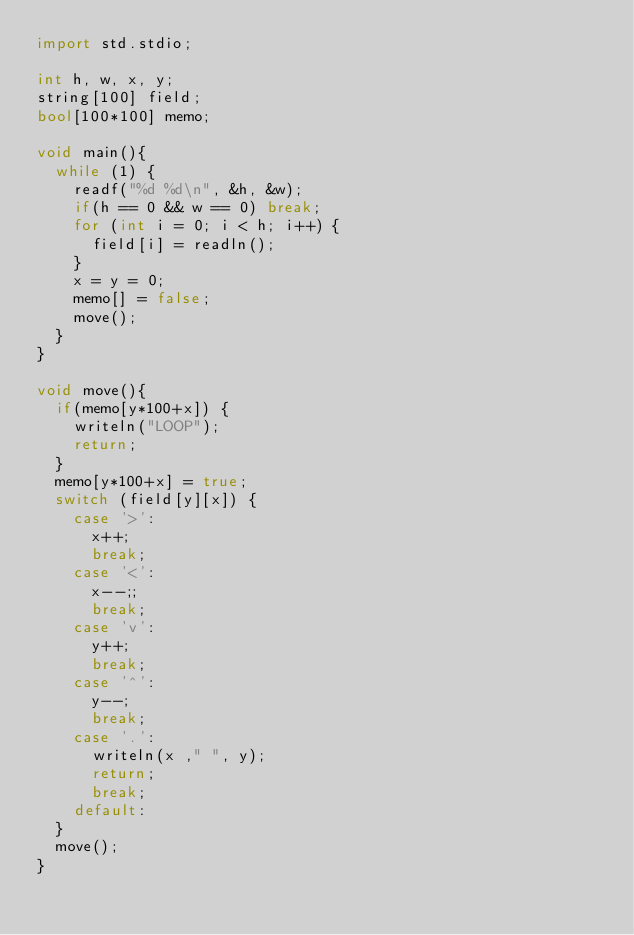Convert code to text. <code><loc_0><loc_0><loc_500><loc_500><_D_>import std.stdio;

int h, w, x, y;
string[100] field;
bool[100*100] memo;

void main(){
	while (1) {
		readf("%d %d\n", &h, &w);
		if(h == 0 && w == 0) break;
		for (int i = 0; i < h; i++) {
			field[i] = readln();
		}
		x = y = 0;
		memo[] = false;
		move();
	}
}

void move(){
	if(memo[y*100+x]) {
		writeln("LOOP");
		return;
	}
	memo[y*100+x] = true;
	switch (field[y][x]) {
		case '>':
			x++;
			break;
		case '<':
			x--;;
			break;
		case 'v':
			y++;
			break;
		case '^':
			y--;
			break;
		case '.':
			writeln(x ," ", y);
			return;
			break;
		default:
	}
	move();
}</code> 